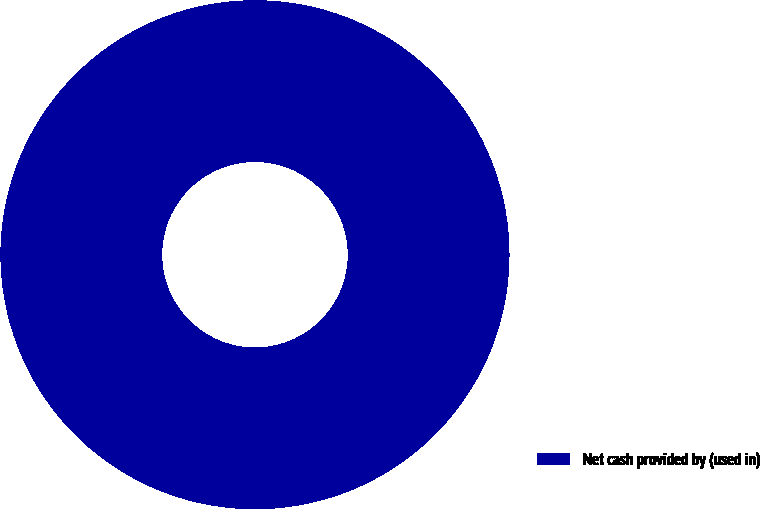Convert chart. <chart><loc_0><loc_0><loc_500><loc_500><pie_chart><fcel>Net cash provided by (used in)<nl><fcel>100.0%<nl></chart> 